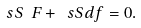Convert formula to latex. <formula><loc_0><loc_0><loc_500><loc_500>\ s S \ F + \ s S d f = 0 .</formula> 